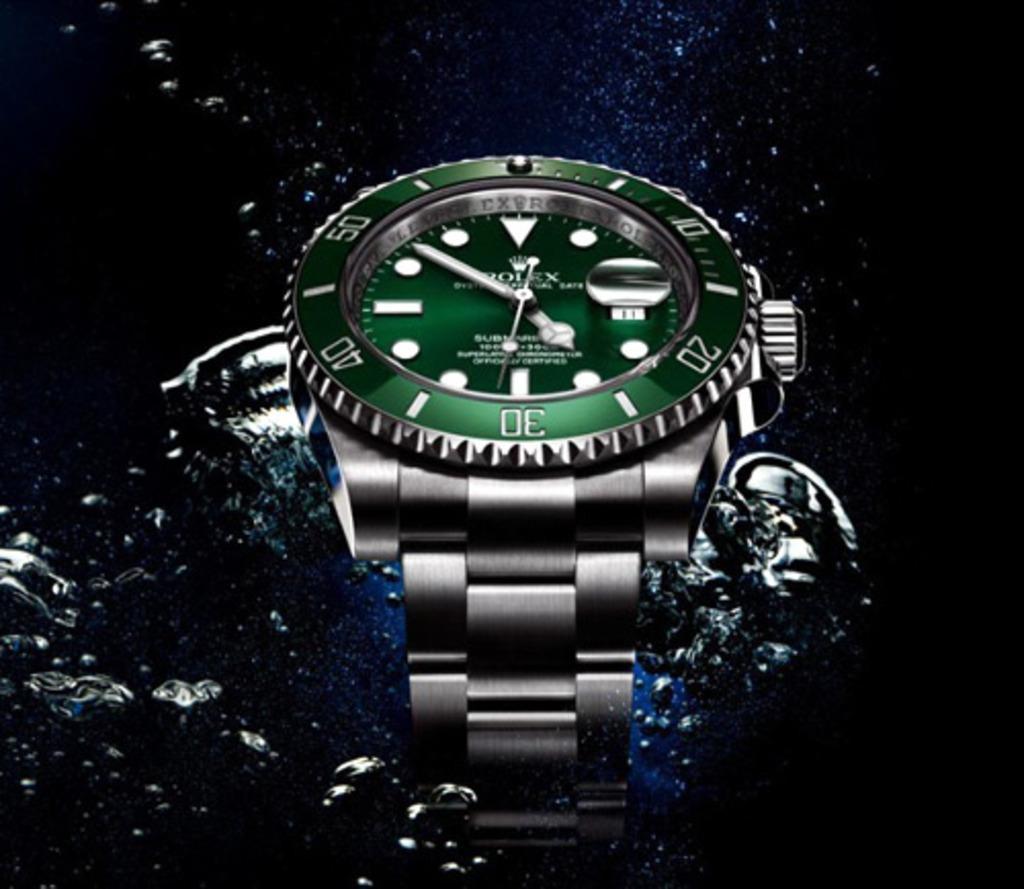Describe this image in one or two sentences. In this image we can see a watch on the water. The background of the image is dark. 